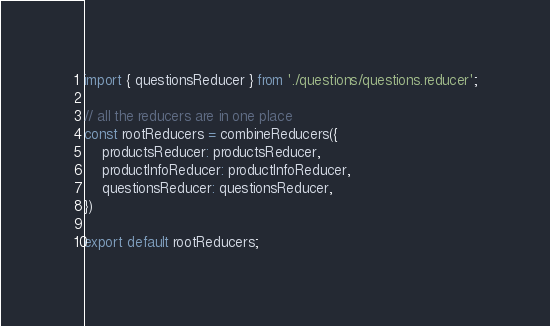<code> <loc_0><loc_0><loc_500><loc_500><_JavaScript_>import { questionsReducer } from './questions/questions.reducer';

// all the reducers are in one place
const rootReducers = combineReducers({
    productsReducer: productsReducer,
    productInfoReducer: productInfoReducer,
    questionsReducer: questionsReducer,
})

export default rootReducers;</code> 